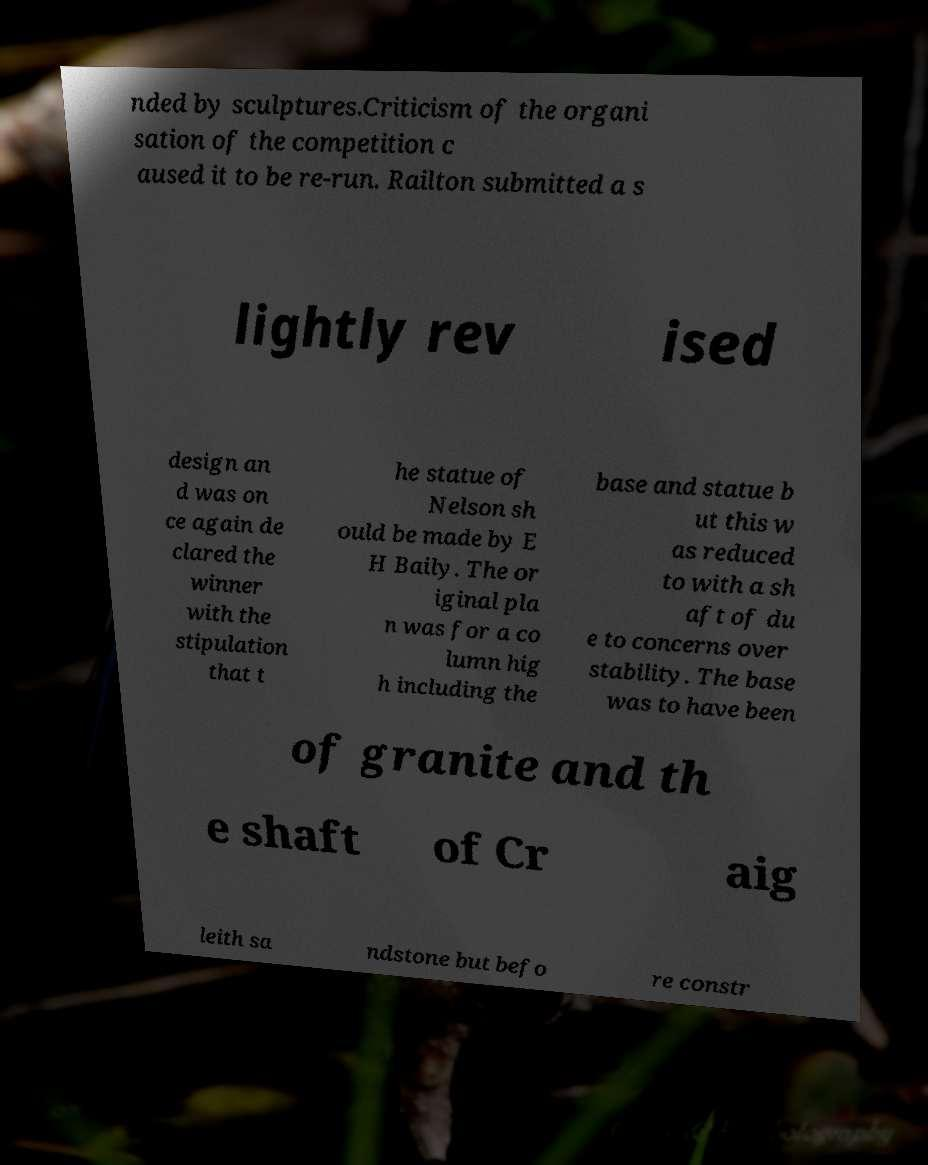What messages or text are displayed in this image? I need them in a readable, typed format. nded by sculptures.Criticism of the organi sation of the competition c aused it to be re-run. Railton submitted a s lightly rev ised design an d was on ce again de clared the winner with the stipulation that t he statue of Nelson sh ould be made by E H Baily. The or iginal pla n was for a co lumn hig h including the base and statue b ut this w as reduced to with a sh aft of du e to concerns over stability. The base was to have been of granite and th e shaft of Cr aig leith sa ndstone but befo re constr 